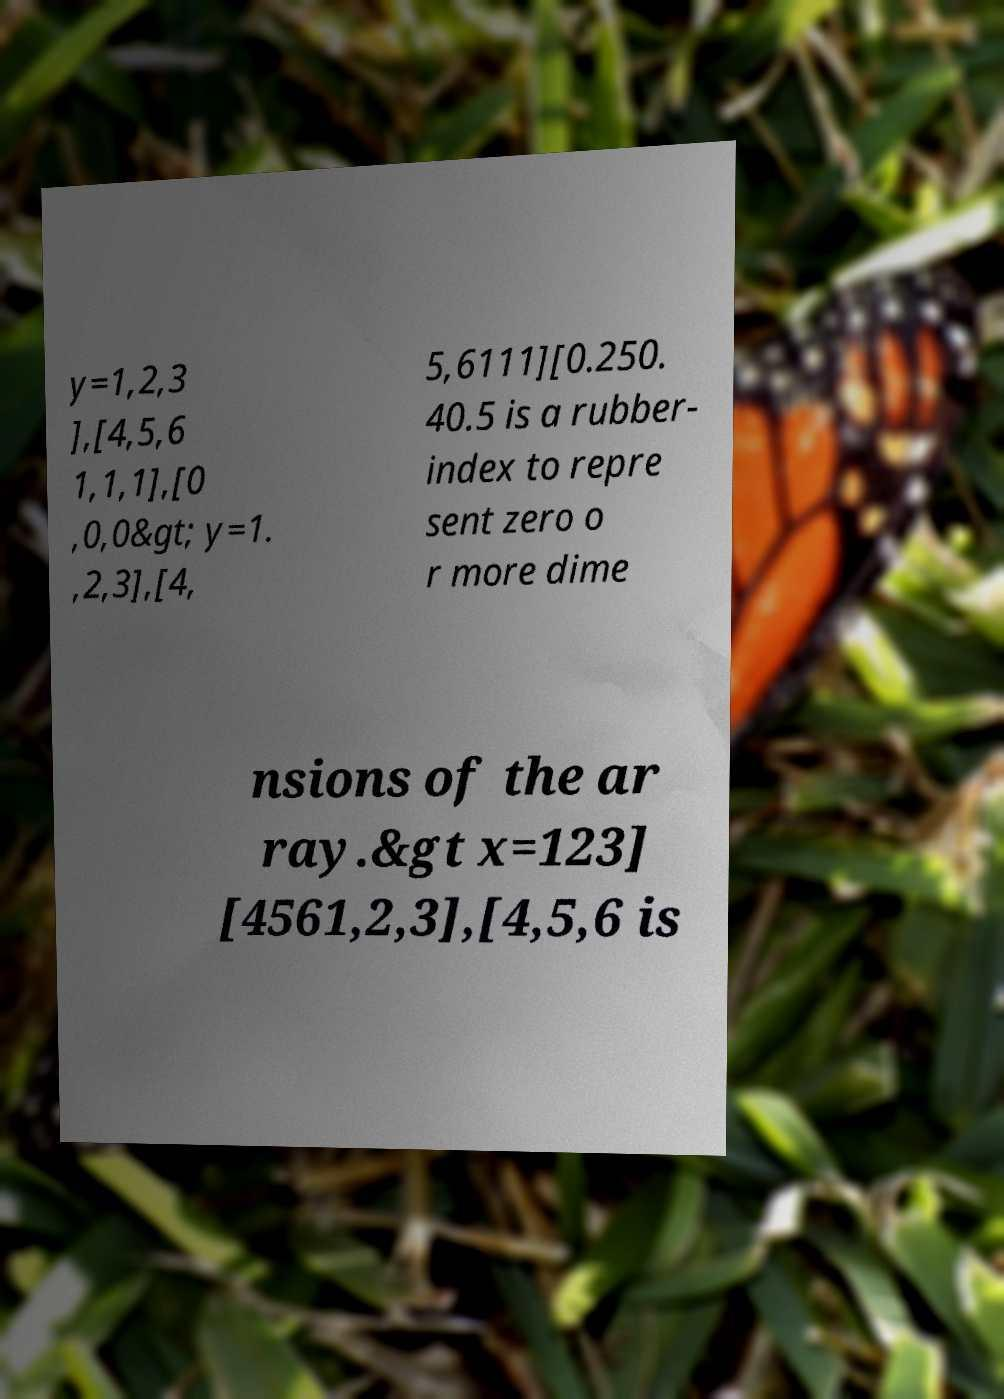Could you assist in decoding the text presented in this image and type it out clearly? y=1,2,3 ],[4,5,6 1,1,1],[0 ,0,0&gt; y=1. ,2,3],[4, 5,6111][0.250. 40.5 is a rubber- index to repre sent zero o r more dime nsions of the ar ray.&gt x=123] [4561,2,3],[4,5,6 is 